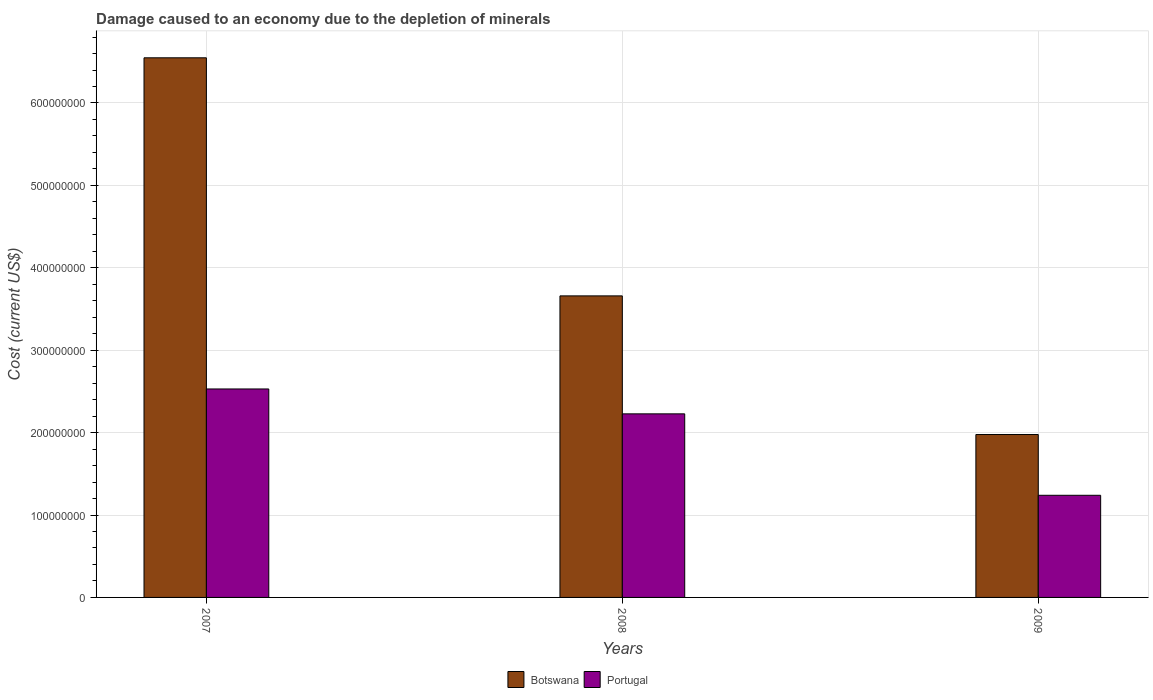Are the number of bars per tick equal to the number of legend labels?
Ensure brevity in your answer.  Yes. Are the number of bars on each tick of the X-axis equal?
Your answer should be very brief. Yes. How many bars are there on the 1st tick from the right?
Offer a terse response. 2. What is the cost of damage caused due to the depletion of minerals in Portugal in 2008?
Provide a short and direct response. 2.23e+08. Across all years, what is the maximum cost of damage caused due to the depletion of minerals in Portugal?
Provide a succinct answer. 2.53e+08. Across all years, what is the minimum cost of damage caused due to the depletion of minerals in Portugal?
Keep it short and to the point. 1.24e+08. In which year was the cost of damage caused due to the depletion of minerals in Portugal maximum?
Your answer should be compact. 2007. What is the total cost of damage caused due to the depletion of minerals in Botswana in the graph?
Ensure brevity in your answer.  1.22e+09. What is the difference between the cost of damage caused due to the depletion of minerals in Portugal in 2007 and that in 2008?
Keep it short and to the point. 3.02e+07. What is the difference between the cost of damage caused due to the depletion of minerals in Botswana in 2008 and the cost of damage caused due to the depletion of minerals in Portugal in 2009?
Make the answer very short. 2.42e+08. What is the average cost of damage caused due to the depletion of minerals in Botswana per year?
Your answer should be compact. 4.06e+08. In the year 2008, what is the difference between the cost of damage caused due to the depletion of minerals in Botswana and cost of damage caused due to the depletion of minerals in Portugal?
Offer a terse response. 1.43e+08. In how many years, is the cost of damage caused due to the depletion of minerals in Portugal greater than 220000000 US$?
Give a very brief answer. 2. What is the ratio of the cost of damage caused due to the depletion of minerals in Botswana in 2008 to that in 2009?
Provide a short and direct response. 1.85. Is the difference between the cost of damage caused due to the depletion of minerals in Botswana in 2007 and 2009 greater than the difference between the cost of damage caused due to the depletion of minerals in Portugal in 2007 and 2009?
Your response must be concise. Yes. What is the difference between the highest and the second highest cost of damage caused due to the depletion of minerals in Botswana?
Provide a short and direct response. 2.89e+08. What is the difference between the highest and the lowest cost of damage caused due to the depletion of minerals in Portugal?
Offer a terse response. 1.29e+08. In how many years, is the cost of damage caused due to the depletion of minerals in Portugal greater than the average cost of damage caused due to the depletion of minerals in Portugal taken over all years?
Offer a terse response. 2. What does the 2nd bar from the left in 2008 represents?
Give a very brief answer. Portugal. What does the 2nd bar from the right in 2007 represents?
Provide a succinct answer. Botswana. How many bars are there?
Your answer should be compact. 6. Are the values on the major ticks of Y-axis written in scientific E-notation?
Give a very brief answer. No. Does the graph contain any zero values?
Your answer should be compact. No. How many legend labels are there?
Provide a succinct answer. 2. How are the legend labels stacked?
Your response must be concise. Horizontal. What is the title of the graph?
Your answer should be very brief. Damage caused to an economy due to the depletion of minerals. Does "Tanzania" appear as one of the legend labels in the graph?
Make the answer very short. No. What is the label or title of the Y-axis?
Your answer should be very brief. Cost (current US$). What is the Cost (current US$) in Botswana in 2007?
Offer a very short reply. 6.55e+08. What is the Cost (current US$) of Portugal in 2007?
Keep it short and to the point. 2.53e+08. What is the Cost (current US$) in Botswana in 2008?
Keep it short and to the point. 3.66e+08. What is the Cost (current US$) of Portugal in 2008?
Make the answer very short. 2.23e+08. What is the Cost (current US$) in Botswana in 2009?
Give a very brief answer. 1.98e+08. What is the Cost (current US$) of Portugal in 2009?
Make the answer very short. 1.24e+08. Across all years, what is the maximum Cost (current US$) of Botswana?
Keep it short and to the point. 6.55e+08. Across all years, what is the maximum Cost (current US$) of Portugal?
Provide a short and direct response. 2.53e+08. Across all years, what is the minimum Cost (current US$) of Botswana?
Give a very brief answer. 1.98e+08. Across all years, what is the minimum Cost (current US$) of Portugal?
Your answer should be very brief. 1.24e+08. What is the total Cost (current US$) of Botswana in the graph?
Provide a short and direct response. 1.22e+09. What is the total Cost (current US$) in Portugal in the graph?
Ensure brevity in your answer.  6.00e+08. What is the difference between the Cost (current US$) of Botswana in 2007 and that in 2008?
Keep it short and to the point. 2.89e+08. What is the difference between the Cost (current US$) of Portugal in 2007 and that in 2008?
Give a very brief answer. 3.02e+07. What is the difference between the Cost (current US$) of Botswana in 2007 and that in 2009?
Offer a terse response. 4.57e+08. What is the difference between the Cost (current US$) in Portugal in 2007 and that in 2009?
Provide a succinct answer. 1.29e+08. What is the difference between the Cost (current US$) in Botswana in 2008 and that in 2009?
Provide a succinct answer. 1.68e+08. What is the difference between the Cost (current US$) in Portugal in 2008 and that in 2009?
Provide a succinct answer. 9.88e+07. What is the difference between the Cost (current US$) in Botswana in 2007 and the Cost (current US$) in Portugal in 2008?
Provide a succinct answer. 4.32e+08. What is the difference between the Cost (current US$) of Botswana in 2007 and the Cost (current US$) of Portugal in 2009?
Make the answer very short. 5.31e+08. What is the difference between the Cost (current US$) in Botswana in 2008 and the Cost (current US$) in Portugal in 2009?
Your answer should be compact. 2.42e+08. What is the average Cost (current US$) in Botswana per year?
Your answer should be compact. 4.06e+08. What is the average Cost (current US$) in Portugal per year?
Offer a very short reply. 2.00e+08. In the year 2007, what is the difference between the Cost (current US$) of Botswana and Cost (current US$) of Portugal?
Your answer should be very brief. 4.02e+08. In the year 2008, what is the difference between the Cost (current US$) in Botswana and Cost (current US$) in Portugal?
Ensure brevity in your answer.  1.43e+08. In the year 2009, what is the difference between the Cost (current US$) of Botswana and Cost (current US$) of Portugal?
Your answer should be compact. 7.37e+07. What is the ratio of the Cost (current US$) of Botswana in 2007 to that in 2008?
Make the answer very short. 1.79. What is the ratio of the Cost (current US$) of Portugal in 2007 to that in 2008?
Offer a very short reply. 1.14. What is the ratio of the Cost (current US$) in Botswana in 2007 to that in 2009?
Offer a very short reply. 3.31. What is the ratio of the Cost (current US$) of Portugal in 2007 to that in 2009?
Ensure brevity in your answer.  2.04. What is the ratio of the Cost (current US$) in Botswana in 2008 to that in 2009?
Provide a short and direct response. 1.85. What is the ratio of the Cost (current US$) in Portugal in 2008 to that in 2009?
Your response must be concise. 1.8. What is the difference between the highest and the second highest Cost (current US$) of Botswana?
Ensure brevity in your answer.  2.89e+08. What is the difference between the highest and the second highest Cost (current US$) of Portugal?
Offer a very short reply. 3.02e+07. What is the difference between the highest and the lowest Cost (current US$) of Botswana?
Offer a very short reply. 4.57e+08. What is the difference between the highest and the lowest Cost (current US$) in Portugal?
Give a very brief answer. 1.29e+08. 